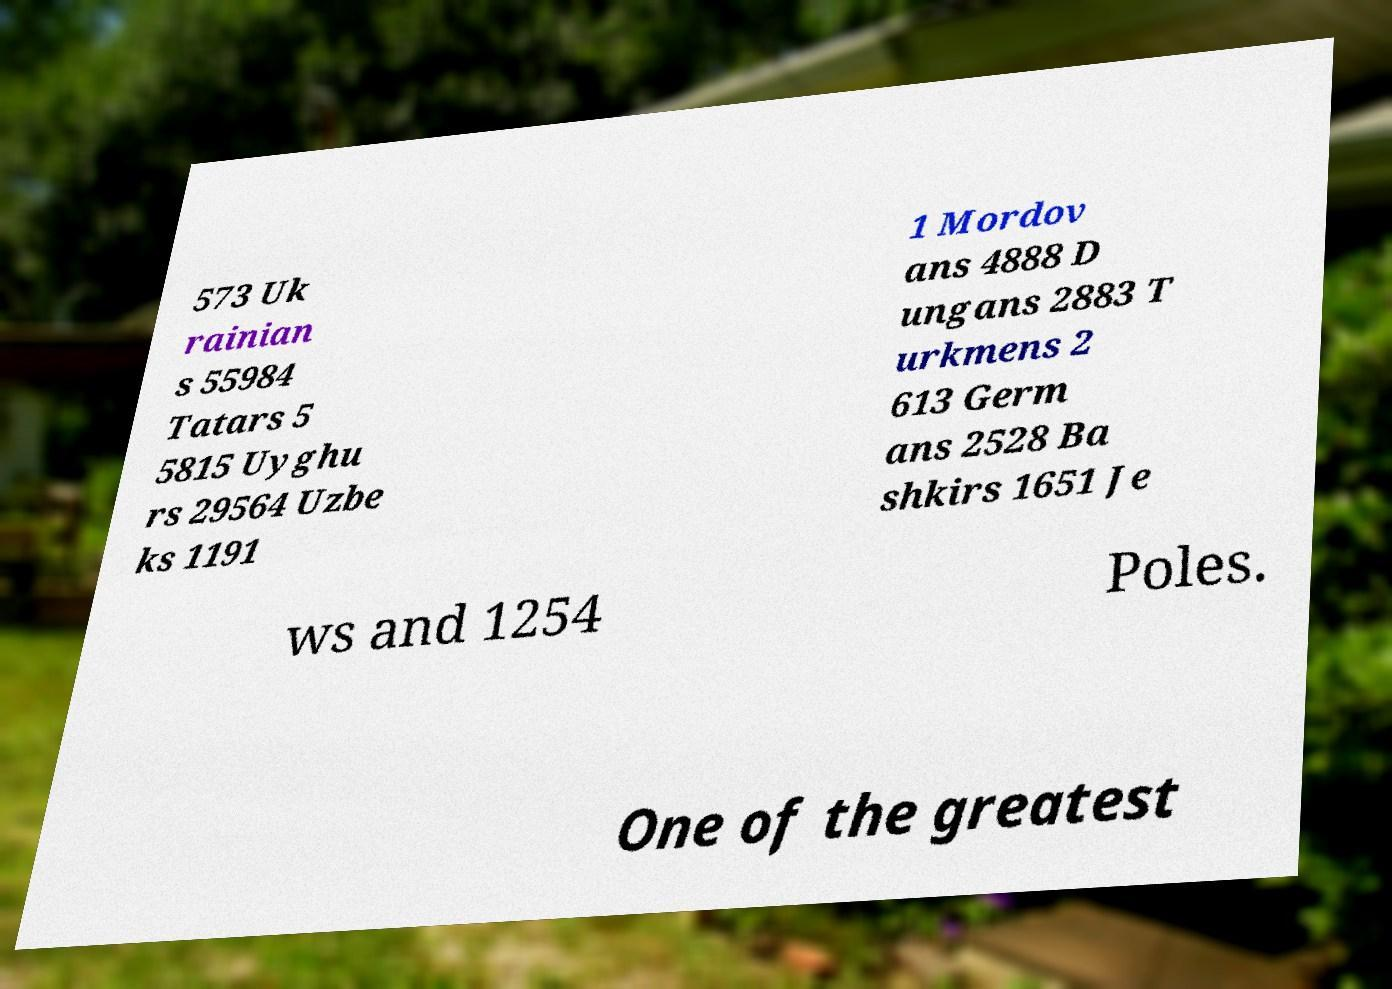Can you accurately transcribe the text from the provided image for me? 573 Uk rainian s 55984 Tatars 5 5815 Uyghu rs 29564 Uzbe ks 1191 1 Mordov ans 4888 D ungans 2883 T urkmens 2 613 Germ ans 2528 Ba shkirs 1651 Je ws and 1254 Poles. One of the greatest 